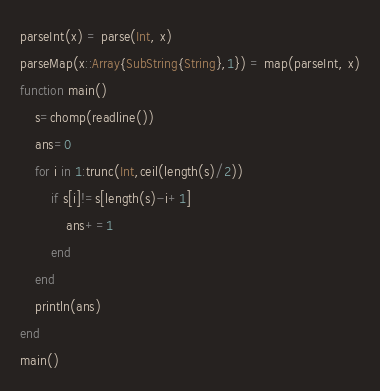<code> <loc_0><loc_0><loc_500><loc_500><_Julia_>parseInt(x) = parse(Int, x)
parseMap(x::Array{SubString{String},1}) = map(parseInt, x)
function main()
    s=chomp(readline())
    ans=0
    for i in 1:trunc(Int,ceil(length(s)/2))
        if s[i]!=s[length(s)-i+1]
            ans+=1
        end
    end
    println(ans)
end
main()</code> 